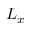<formula> <loc_0><loc_0><loc_500><loc_500>L _ { x }</formula> 